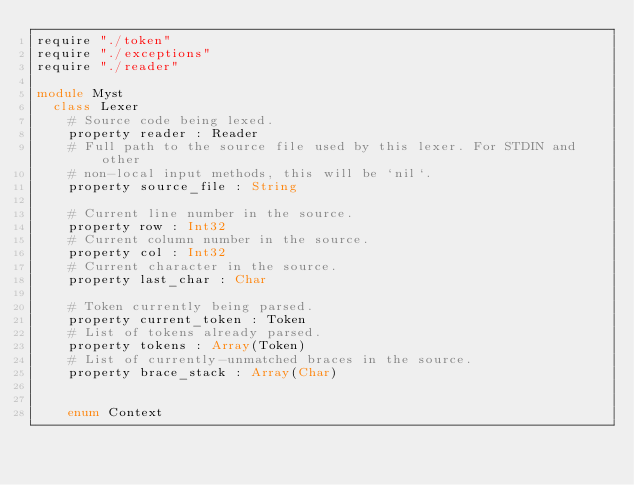Convert code to text. <code><loc_0><loc_0><loc_500><loc_500><_Crystal_>require "./token"
require "./exceptions"
require "./reader"

module Myst
  class Lexer
    # Source code being lexed.
    property reader : Reader
    # Full path to the source file used by this lexer. For STDIN and other
    # non-local input methods, this will be `nil`.
    property source_file : String

    # Current line number in the source.
    property row : Int32
    # Current column number in the source.
    property col : Int32
    # Current character in the source.
    property last_char : Char

    # Token currently being parsed.
    property current_token : Token
    # List of tokens already parsed.
    property tokens : Array(Token)
    # List of currently-unmatched braces in the source.
    property brace_stack : Array(Char)


    enum Context</code> 